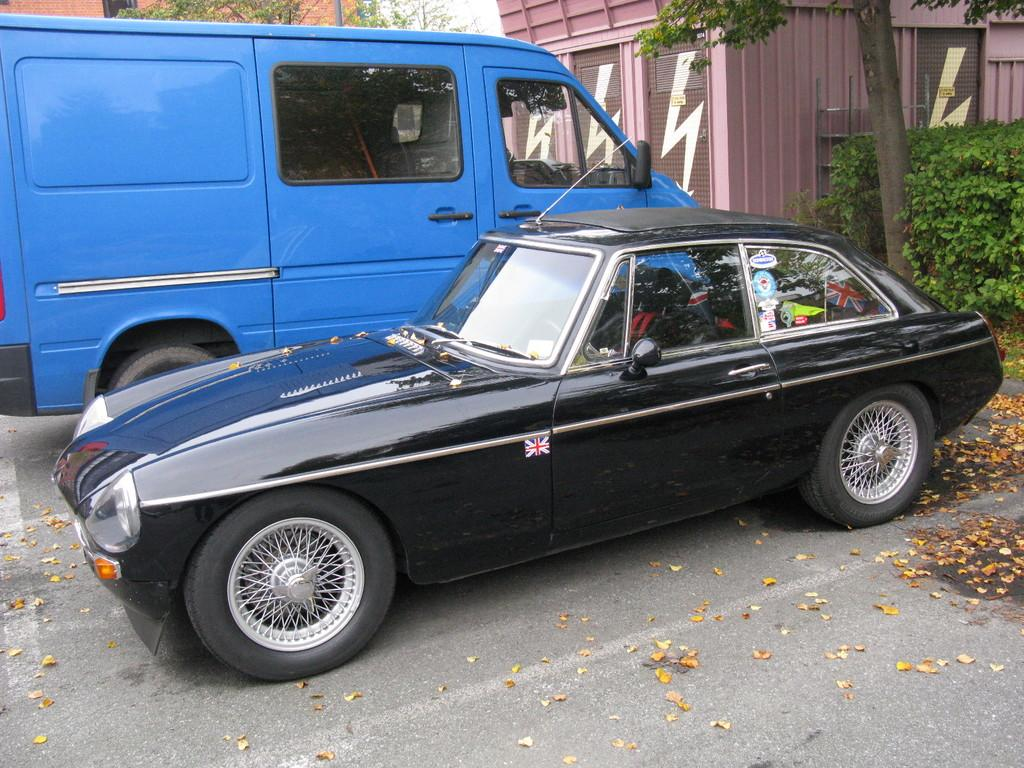What type of vehicle is located on the left side of the image? There is a black car on the left side of the image. What type of vehicle is located on the right side of the image? There is a blue van on the right side of the image. What can be seen in the background of the image? There are bushes, trees, and buildings in the background of the image. What is present on the road in the front of the image? There are leaves on the road in the front of the image. What type of behavior can be observed in the letter in the image? There is no letter present in the image, so it is not possible to observe any behavior. 